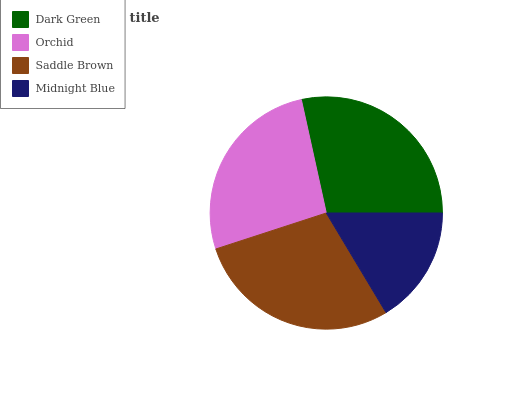Is Midnight Blue the minimum?
Answer yes or no. Yes. Is Saddle Brown the maximum?
Answer yes or no. Yes. Is Orchid the minimum?
Answer yes or no. No. Is Orchid the maximum?
Answer yes or no. No. Is Dark Green greater than Orchid?
Answer yes or no. Yes. Is Orchid less than Dark Green?
Answer yes or no. Yes. Is Orchid greater than Dark Green?
Answer yes or no. No. Is Dark Green less than Orchid?
Answer yes or no. No. Is Dark Green the high median?
Answer yes or no. Yes. Is Orchid the low median?
Answer yes or no. Yes. Is Saddle Brown the high median?
Answer yes or no. No. Is Dark Green the low median?
Answer yes or no. No. 